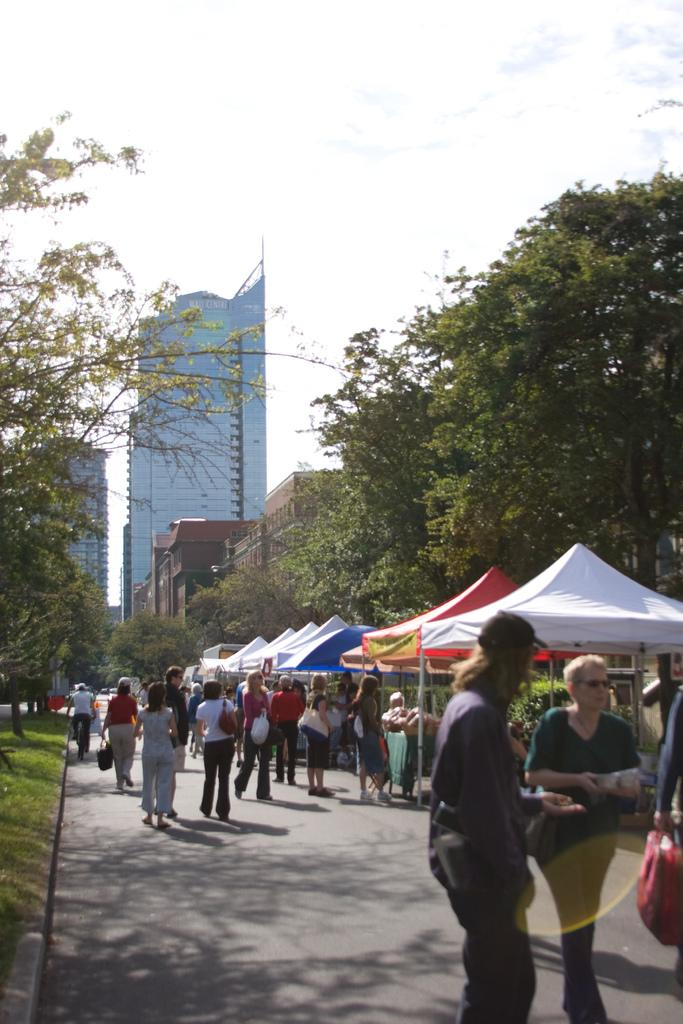What can be seen in the sky in the image? The sky is visible in the image. What type of natural elements are present in the image? There are trees in the image. What type of man-made structures can be seen in the image? There are buildings in the image. What is the surface on which the persons are standing? The ground is visible in the image. What are the persons doing in the image? There are persons standing on the ground. What type of temporary shelters are present in the image? Tents are present in the image. What type of seed can be seen growing on the toes of the persons in the image? There is no seed or mention of toes in the image; it features persons standing on the ground and other elements such as trees, buildings, and tents. 